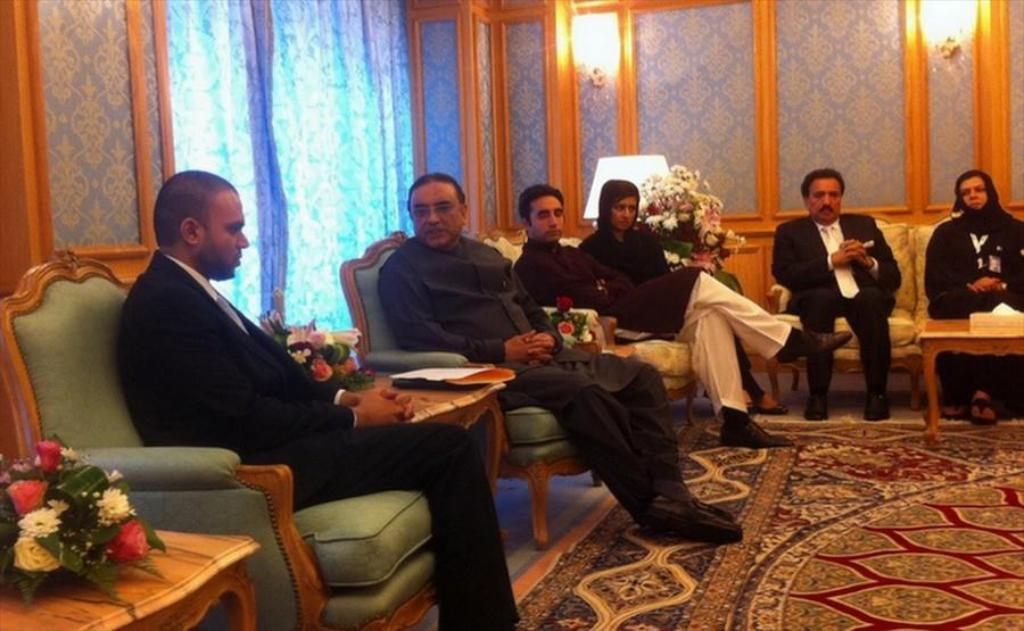What are the people in the image doing? The people in the image are sitting on chairs. What can be seen in the image besides the people sitting on chairs? There are flowers visible in the image. What type of lighting is present in the image? There are two lights on the wall in the image. How many dogs are present in the image? There are no dogs visible in the image. What type of produce can be seen in the image? There is no produce present in the image. 